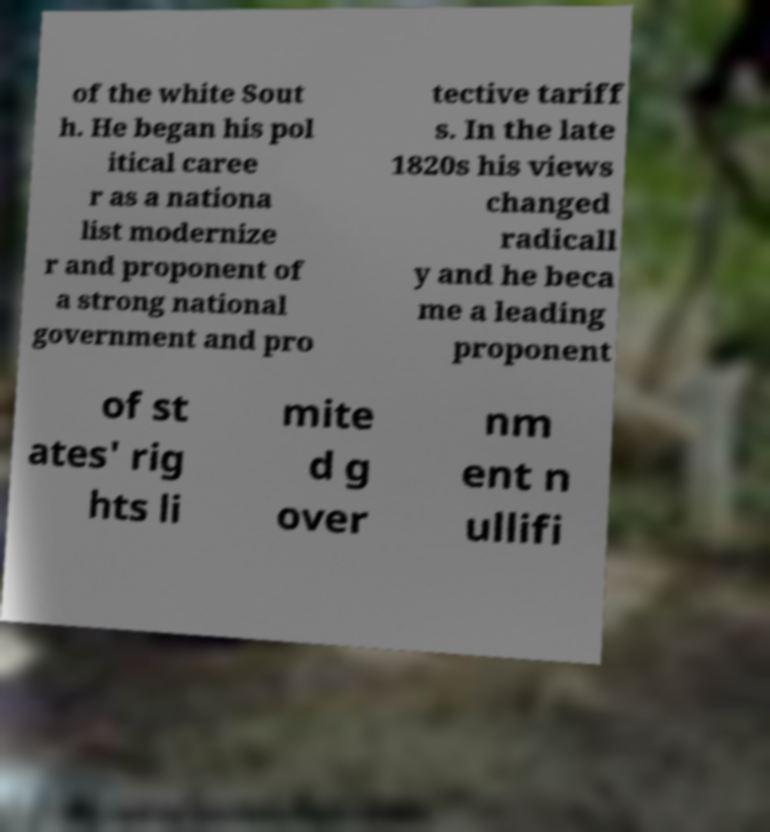Could you assist in decoding the text presented in this image and type it out clearly? of the white Sout h. He began his pol itical caree r as a nationa list modernize r and proponent of a strong national government and pro tective tariff s. In the late 1820s his views changed radicall y and he beca me a leading proponent of st ates' rig hts li mite d g over nm ent n ullifi 